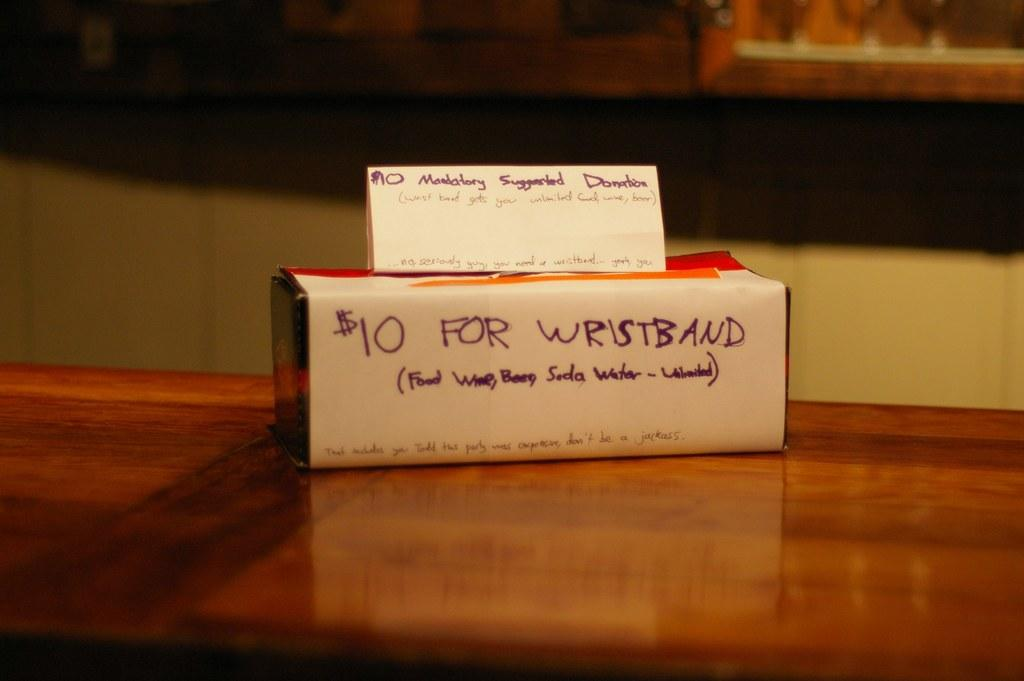Provide a one-sentence caption for the provided image. The white box says it is $10 for a wristband. 